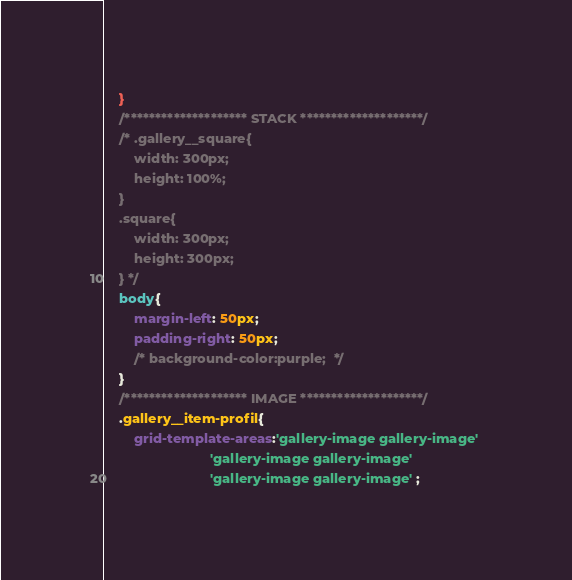<code> <loc_0><loc_0><loc_500><loc_500><_CSS_>	}
	/******************** STACK ********************/
	/* .gallery__square{
		width: 300px;
		height: 100%;
	}
	.square{
		width: 300px;
		height: 300px; 
	} */ 
	body{
		margin-left: 50px; 
		padding-right: 50px;
		/* background-color:purple;  */
	}
	/******************** IMAGE ********************/
	.gallery__item-profil{
		grid-template-areas:'gallery-image gallery-image' 
							'gallery-image gallery-image' 
							'gallery-image gallery-image' ;</code> 